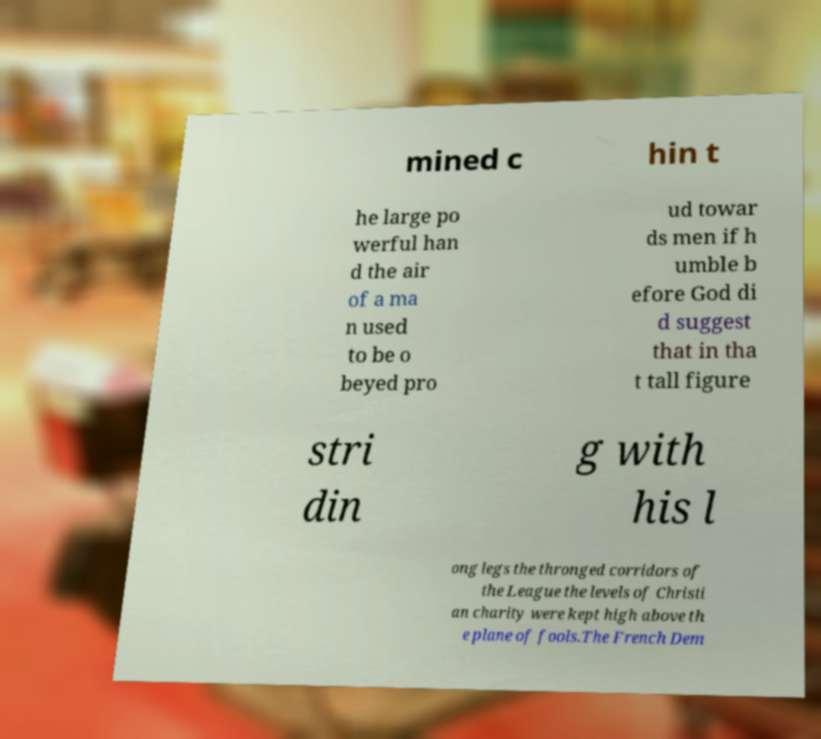Can you read and provide the text displayed in the image?This photo seems to have some interesting text. Can you extract and type it out for me? mined c hin t he large po werful han d the air of a ma n used to be o beyed pro ud towar ds men if h umble b efore God di d suggest that in tha t tall figure stri din g with his l ong legs the thronged corridors of the League the levels of Christi an charity were kept high above th e plane of fools.The French Dem 